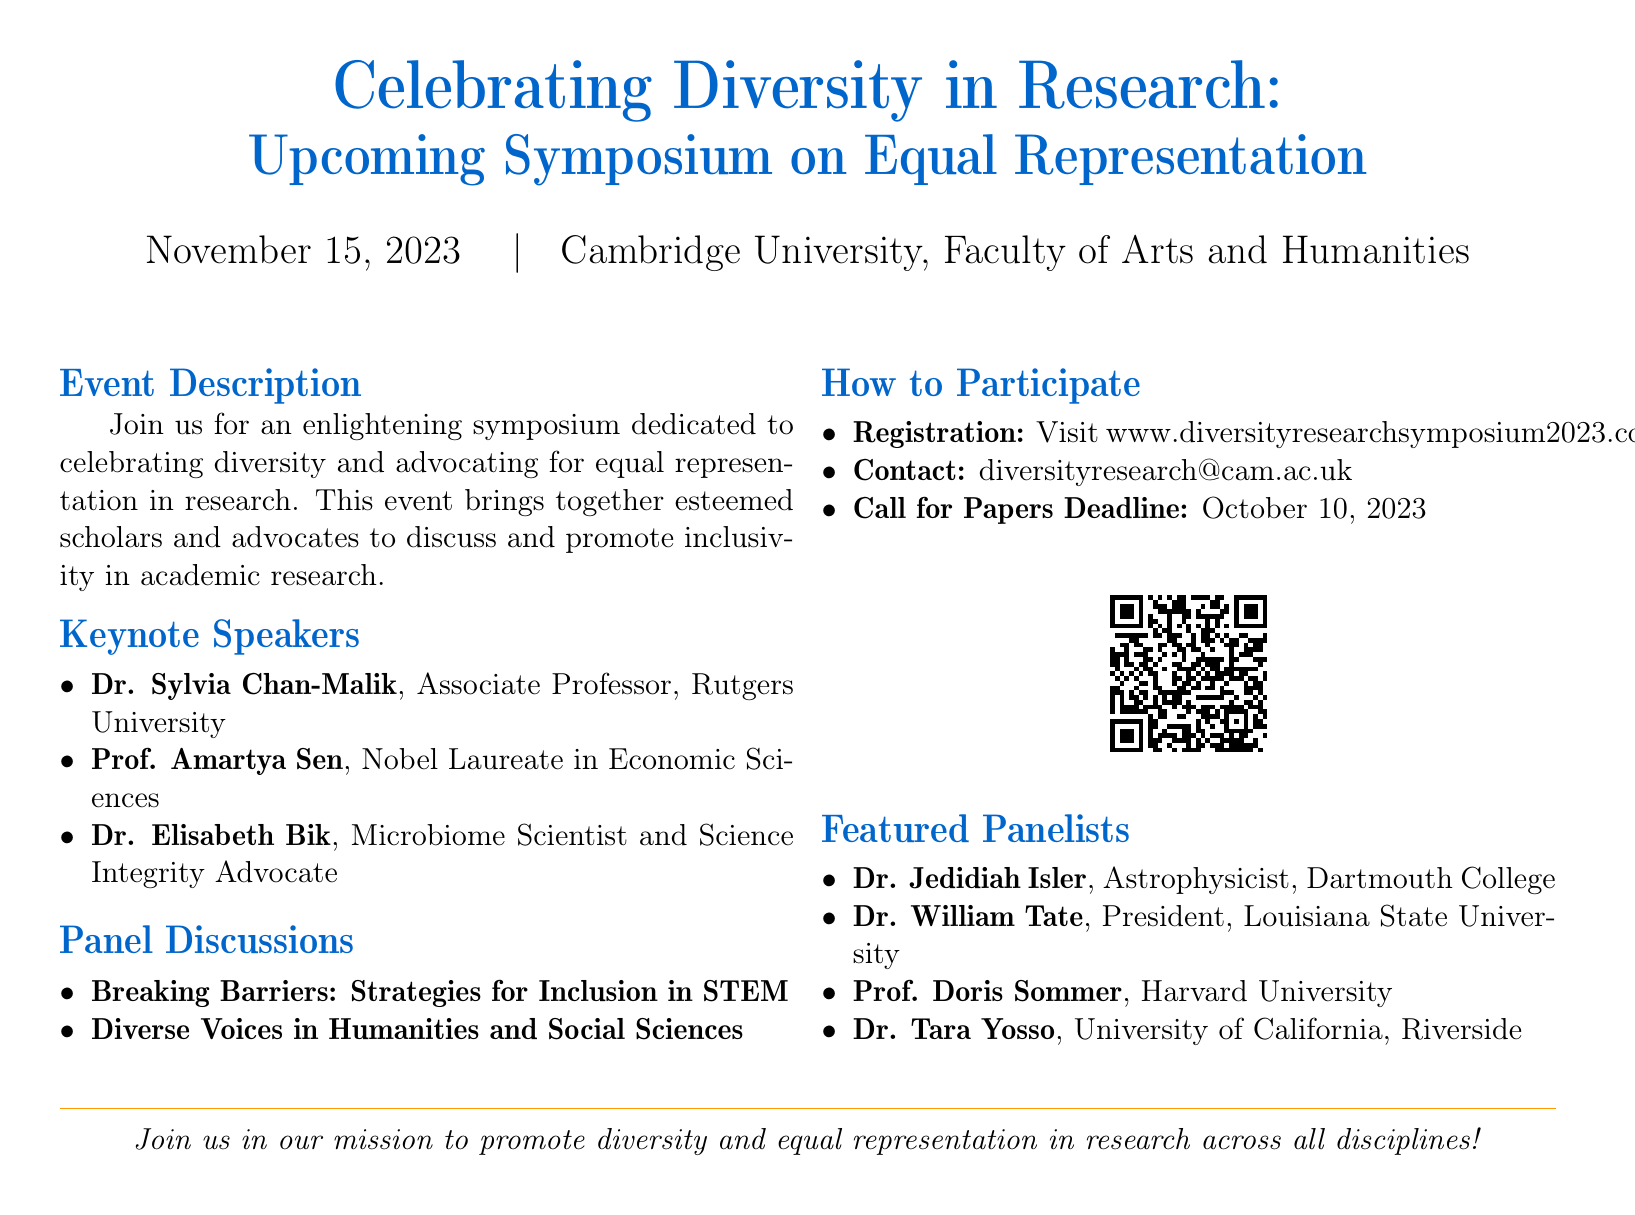What is the date of the symposium? The date of the symposium is explicitly stated in the document as November 15, 2023.
Answer: November 15, 2023 Where is the event being held? The event location is specified as Cambridge University, Faculty of Arts and Humanities in the document.
Answer: Cambridge University, Faculty of Arts and Humanities Who is a keynote speaker at the symposium? The document lists several keynote speakers, one of whom is Dr. Sylvia Chan-Malik.
Answer: Dr. Sylvia Chan-Malik What is the call for papers deadline? The deadline for the call for papers is mentioned in the document as October 10, 2023.
Answer: October 10, 2023 What is the main theme of the symposium? The theme of the symposium is highlighted in the event description, focusing on celebrating diversity and advocating for equal representation.
Answer: Celebrating diversity and advocating for equal representation What are the two panel discussion topics? The document outlines two panel discussion topics: Breaking Barriers: Strategies for Inclusion in STEM and Diverse Voices in Humanities and Social Sciences.
Answer: Breaking Barriers: Strategies for Inclusion in STEM, Diverse Voices in Humanities and Social Sciences How can participants register for the event? The document provides a website for registration: www.diversityresearchsymposium2023.com.
Answer: www.diversityresearchsymposium2023.com What color is designated as the primary color in the document? The primary color used in the document is specified as RGB(0,102,204).
Answer: RGB(0,102,204) 